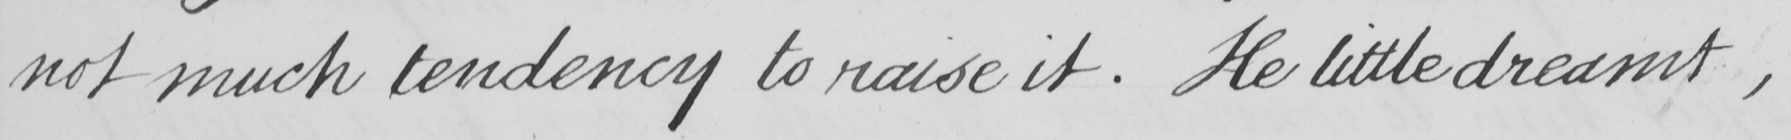What text is written in this handwritten line? not much tendency to raise it . He little dreamt , 